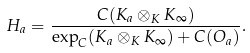Convert formula to latex. <formula><loc_0><loc_0><loc_500><loc_500>H _ { a } = \frac { C ( K _ { a } \otimes _ { K } K _ { \infty } ) } { \exp _ { C } ( K _ { a } \otimes _ { K } K _ { \infty } ) + C ( O _ { a } ) } .</formula> 